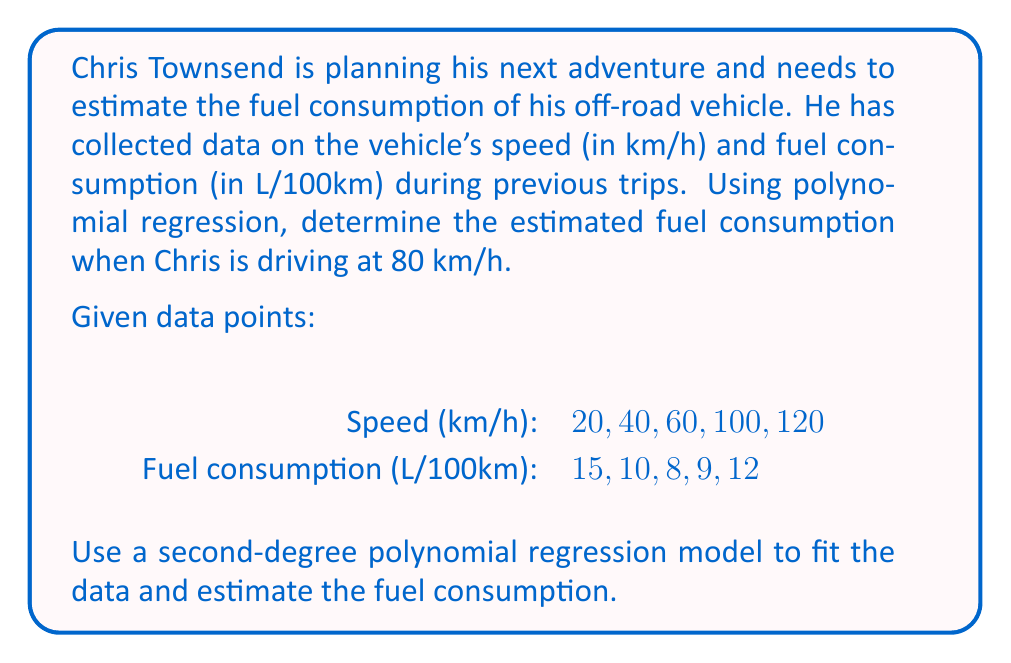Solve this math problem. To solve this problem, we'll follow these steps:

1. Set up the second-degree polynomial regression equation:
   $$ y = ax^2 + bx + c $$
   where $y$ is fuel consumption and $x$ is speed.

2. Use the given data points to create a system of equations:
   $$ 15 = 400a + 20b + c $$
   $$ 10 = 1600a + 40b + c $$
   $$ 8 = 3600a + 60b + c $$
   $$ 9 = 10000a + 100b + c $$
   $$ 12 = 14400a + 120b + c $$

3. Solve the system of equations using a matrix method or a calculator with linear regression capabilities. This gives us the values of $a$, $b$, and $c$.

4. The resulting polynomial regression equation is:
   $$ y = 0.00125x^2 - 0.1375x + 12.75 $$

5. To estimate fuel consumption at 80 km/h, substitute $x = 80$ into the equation:
   $$ y = 0.00125(80)^2 - 0.1375(80) + 12.75 $$
   $$ y = 0.00125(6400) - 11 + 12.75 $$
   $$ y = 8 - 11 + 12.75 $$
   $$ y = 9.75 $$

Therefore, the estimated fuel consumption when Chris is driving at 80 km/h is 9.75 L/100km.
Answer: 9.75 L/100km 